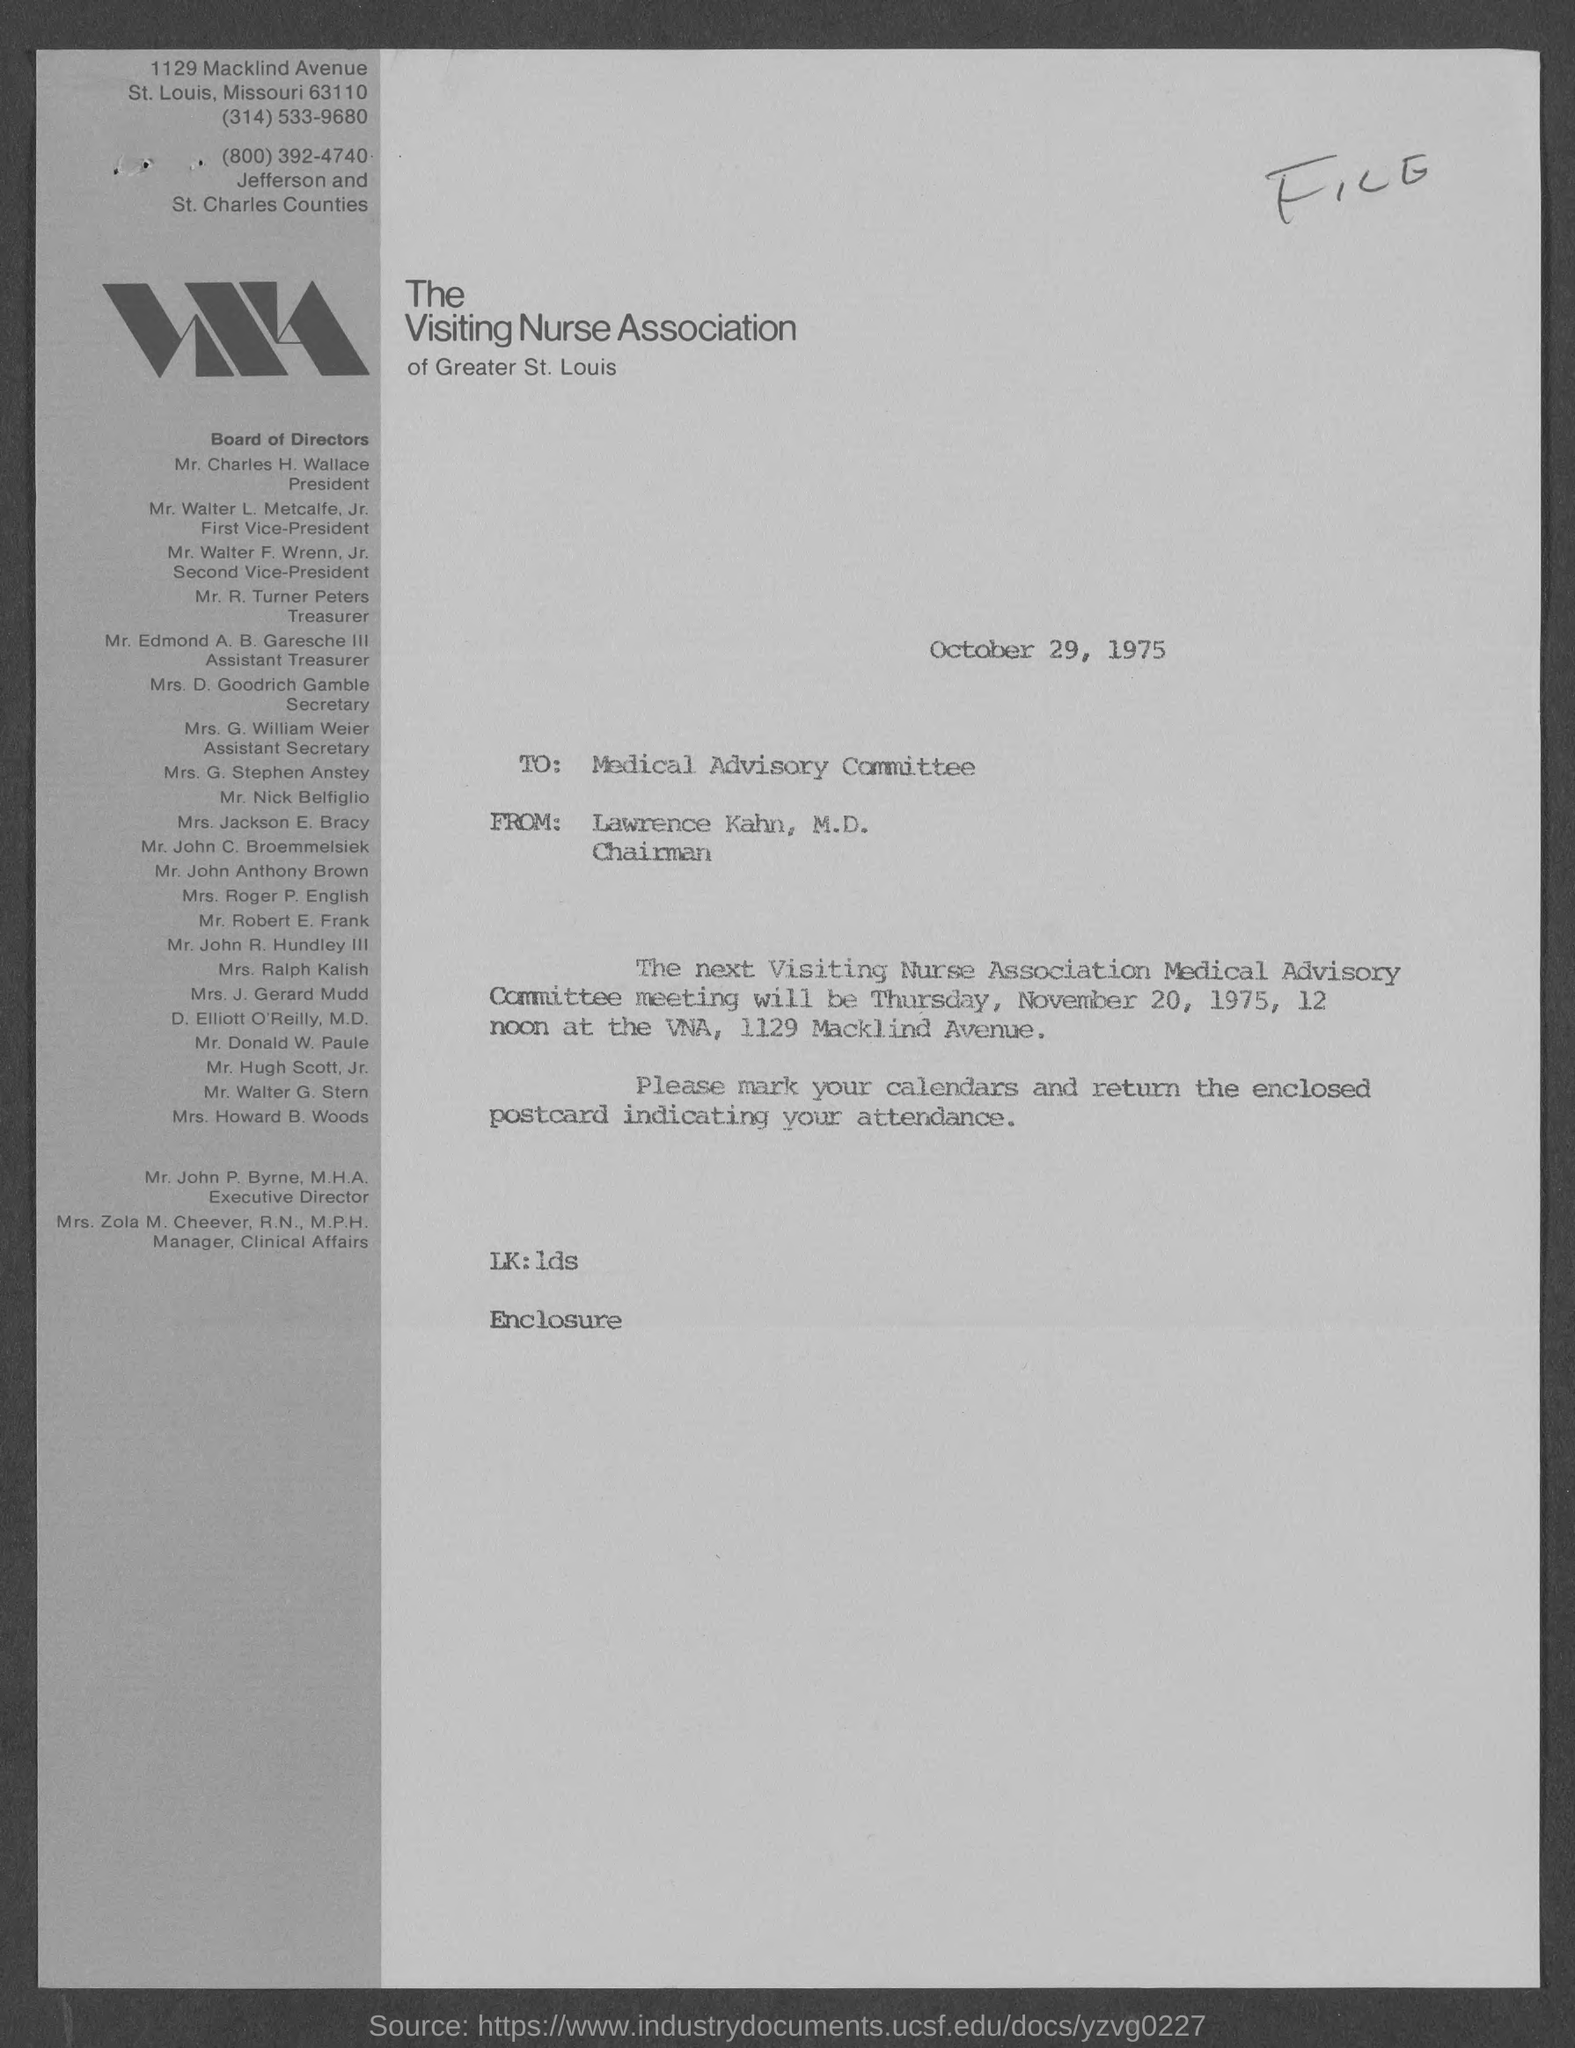Mention a couple of crucial points in this snapshot. The memorandum is dated October 29, 1975. What is a from address in a memorandum? It is "Lawrence Khan, M.D.," according to the original message. Mr. Walter L. Metcalfe, Jr. holds the position of first vice president. Mr. Edmond A. B. Garesche III holds the position of assistant treasurer. Mr. Charles H. Wallace is the President. 